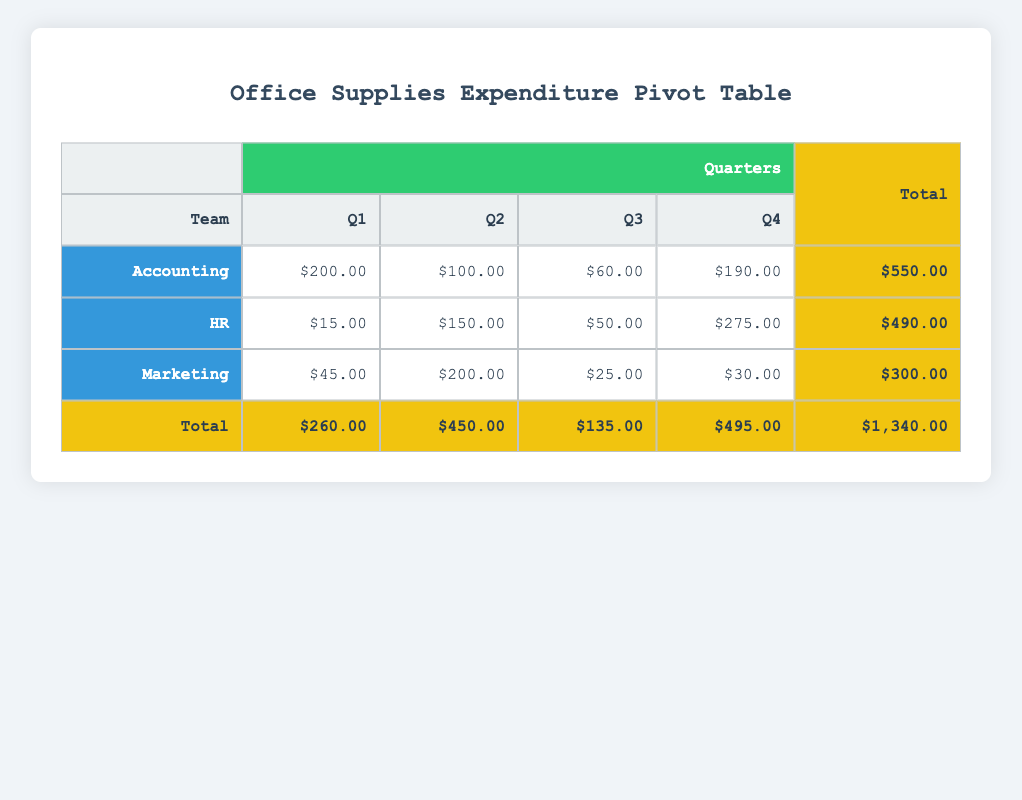What was the total expenditure of the Accounting team in Q1? The total expenditure for the Accounting team in Q1 can be found by looking at the Q1 column for the Accounting row. It shows a cost of $200.00.
Answer: 200.00 Which team spent the most in Q4? To determine which team spent the most in Q4, we compare the Q4 expenditures: Accounting has $190.00, HR has $275.00, and Marketing has $30.00. HR has the highest amount at $275.00.
Answer: HR What is the total expenditure across all teams for Q2? The total expenditure for Q2 can be calculated by adding the values of Q2: Accounting is $100.00, HR is $150.00, and Marketing is $200.00. Summing these amounts gives $100.00 + $150.00 + $200.00 = $450.00.
Answer: 450.00 Did Marketing spend more in Q3 or Q4? To compare Marketing's expenditures, we check Q3, which is $25.00, and Q4, which is $30.00. Since $30.00 is greater than $25.00, Marketing spent more in Q4 than in Q3.
Answer: Yes What is the average expenditure of the HR team across all quarters? To find the average, we first sum the HR expenditures for all quarters: Q1 is $15.00, Q2 is $150.00, Q3 is $50.00, and Q4 is $275.00. Adding these gives $15.00 + $150.00 + $50.00 + $275.00 = $490.00. There are 4 quarters, so the average is $490.00 / 4 = $122.50.
Answer: 122.50 Which item had the highest quantity purchased by the Accounting team in Q1? In Q1 for the Accounting team, the quantities purchased are 150 for Pens and 50 for Notebooks. Therefore, Pens had the highest quantity purchased at 150.
Answer: Pens If we consider total expenditure per item for HR, which item cost the most? By looking at the expenditure values for HR, the costs are $15.00 for Staples, $150.00 for Printer Paper, $50.00 for Sticky Notes, and $275.00 for File Folders, which indicates that File Folders, at $275.00, cost the most.
Answer: File Folders What is the total expenditure of all teams for the entire year? To calculate the yearly total, we sum all totals: Accounting's total is $550.00, HR's total is $490.00, and Marketing's total is $300.00. Adding these together gives $550.00 + $490.00 + $300.00 = $1,340.00.
Answer: 1340.00 Which team had the lowest total expenditure? Looking at the total expenditures: Accounting is $550.00, HR is $490.00, and Marketing is $300.00. Marketing has the lowest total expenditure.
Answer: Marketing 